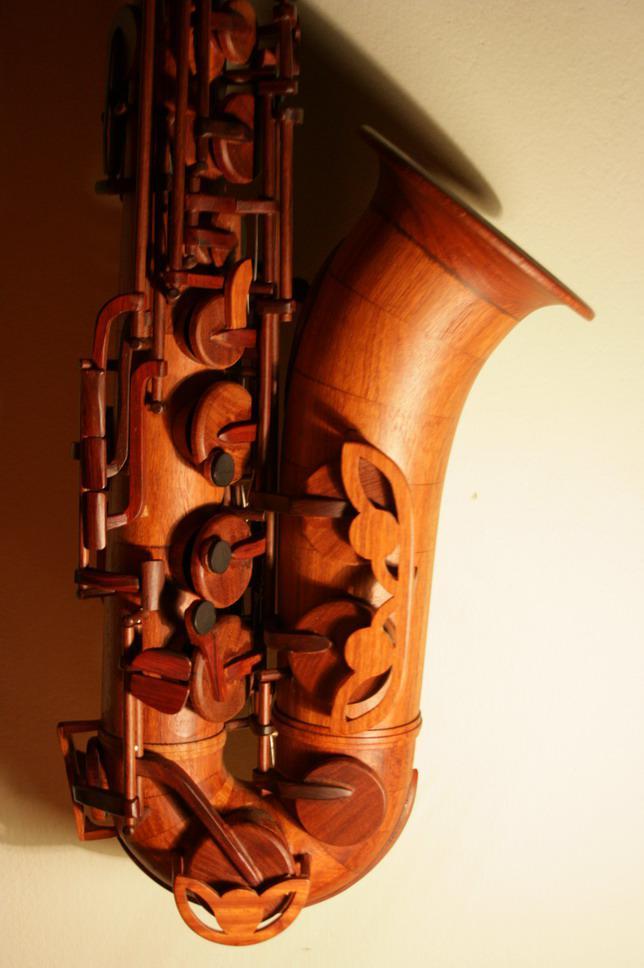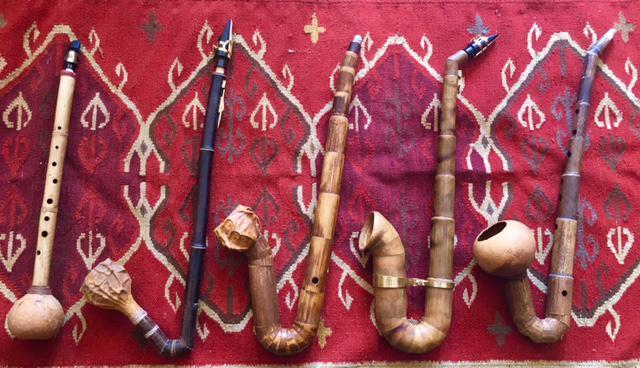The first image is the image on the left, the second image is the image on the right. Assess this claim about the two images: "At least one image contains multiple saxophones.". Correct or not? Answer yes or no. Yes. 